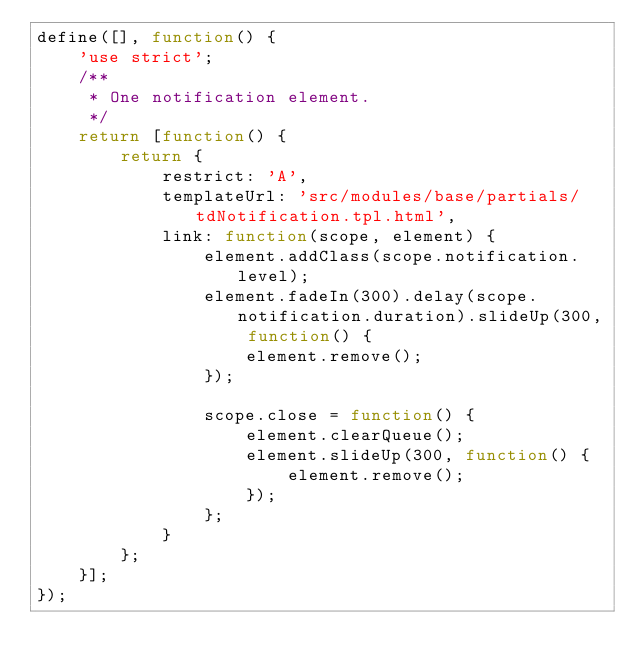<code> <loc_0><loc_0><loc_500><loc_500><_JavaScript_>define([], function() {
    'use strict';
    /**
     * One notification element.
     */
    return [function() {
        return {
            restrict: 'A',
            templateUrl: 'src/modules/base/partials/tdNotification.tpl.html',
            link: function(scope, element) {
                element.addClass(scope.notification.level);
                element.fadeIn(300).delay(scope.notification.duration).slideUp(300, function() {
                    element.remove();
                });

                scope.close = function() {
                    element.clearQueue();
                    element.slideUp(300, function() {
                        element.remove();
                    });
                };
            }
        };
    }];
});</code> 